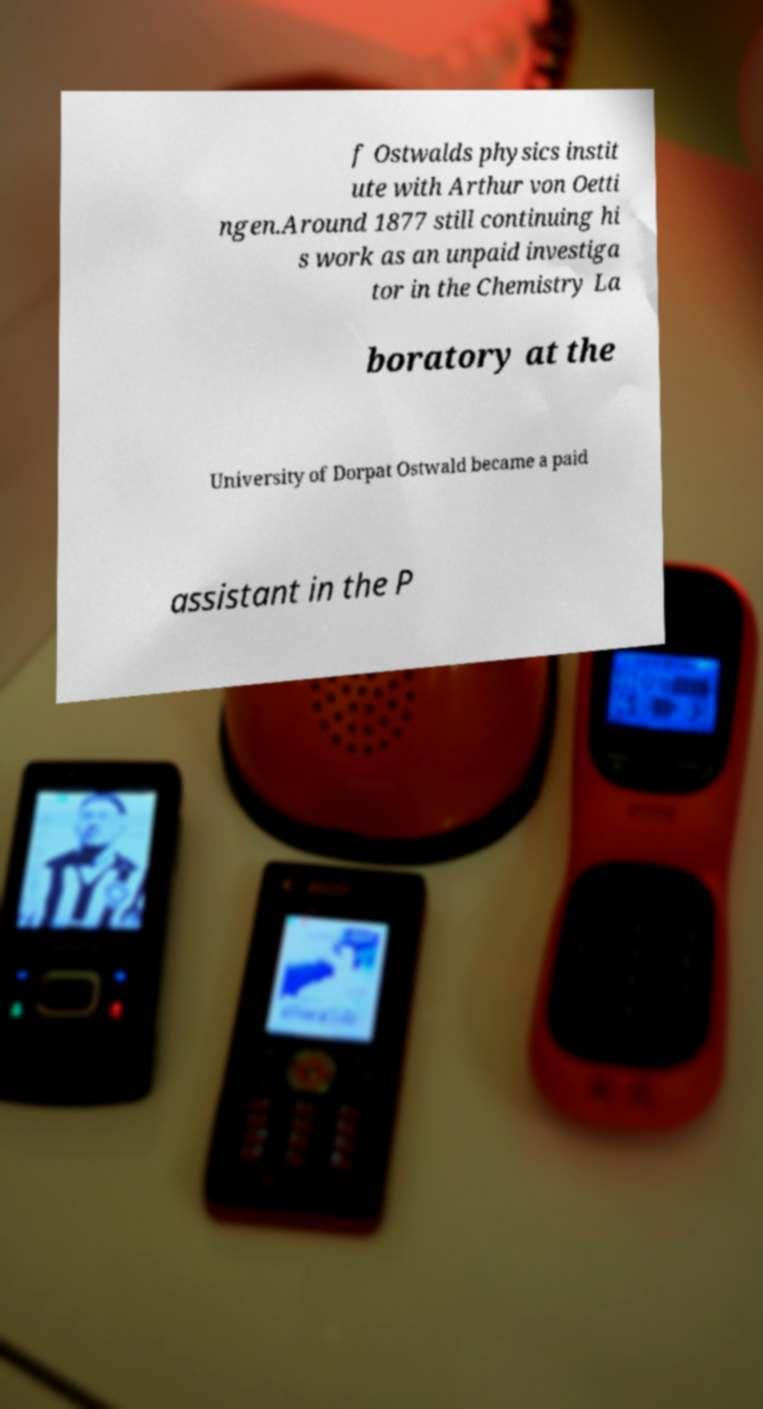Please read and relay the text visible in this image. What does it say? f Ostwalds physics instit ute with Arthur von Oetti ngen.Around 1877 still continuing hi s work as an unpaid investiga tor in the Chemistry La boratory at the University of Dorpat Ostwald became a paid assistant in the P 